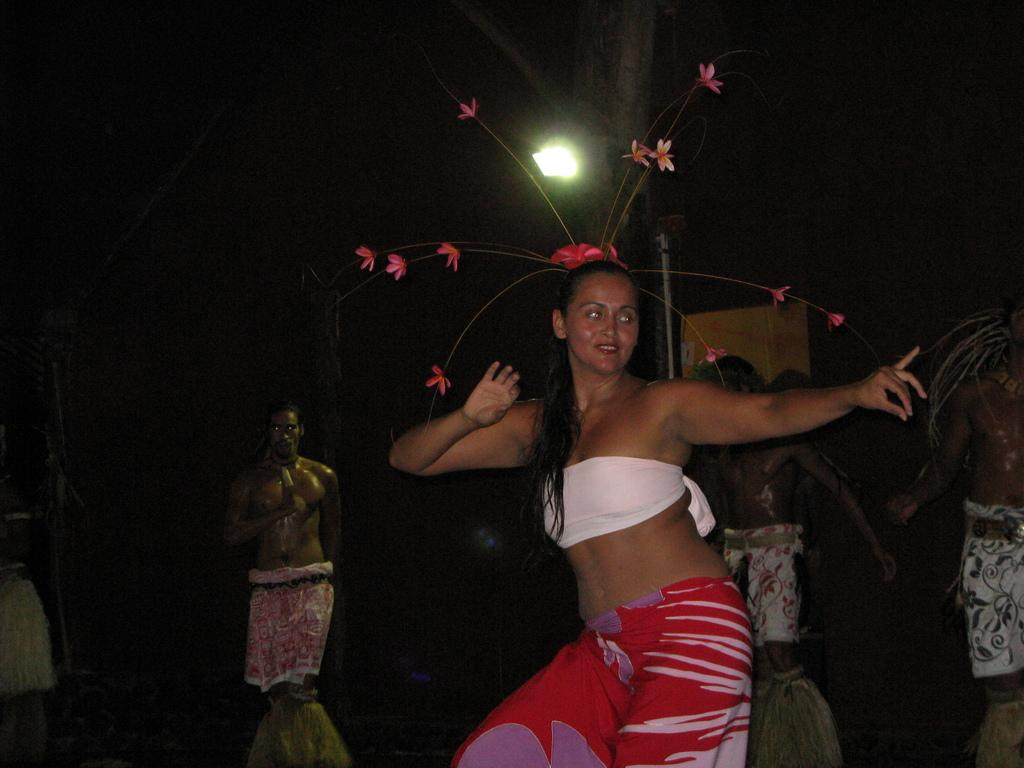What is the main subject of the image? There is a woman standing in the image. What is the woman doing in the image? The woman is looking to the right. What can be seen in the background of the image? There is a flower pot and people in the background of the image. How would you describe the lighting in the image? The background of the image is dark. Can you hear the woman laughing in the image? There is no sound in the image, so we cannot hear the woman laughing. Is there a flame visible in the image? There is no flame present in the image. 